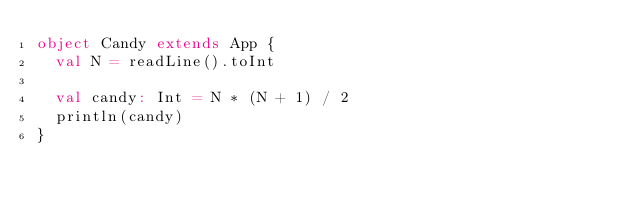Convert code to text. <code><loc_0><loc_0><loc_500><loc_500><_Scala_>object Candy extends App {
  val N = readLine().toInt

  val candy: Int = N * (N + 1) / 2
  println(candy)
}</code> 